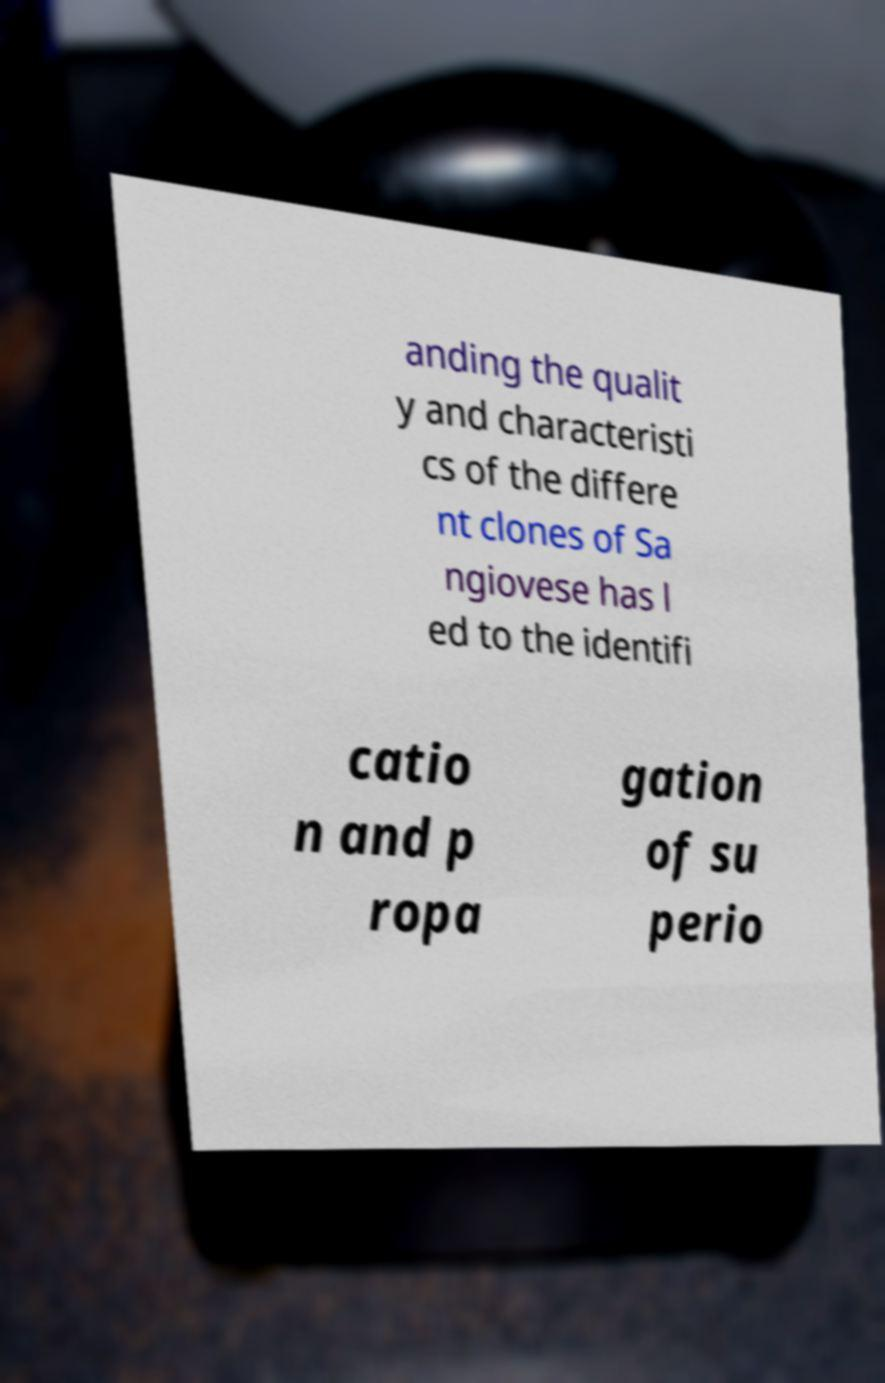Could you assist in decoding the text presented in this image and type it out clearly? anding the qualit y and characteristi cs of the differe nt clones of Sa ngiovese has l ed to the identifi catio n and p ropa gation of su perio 